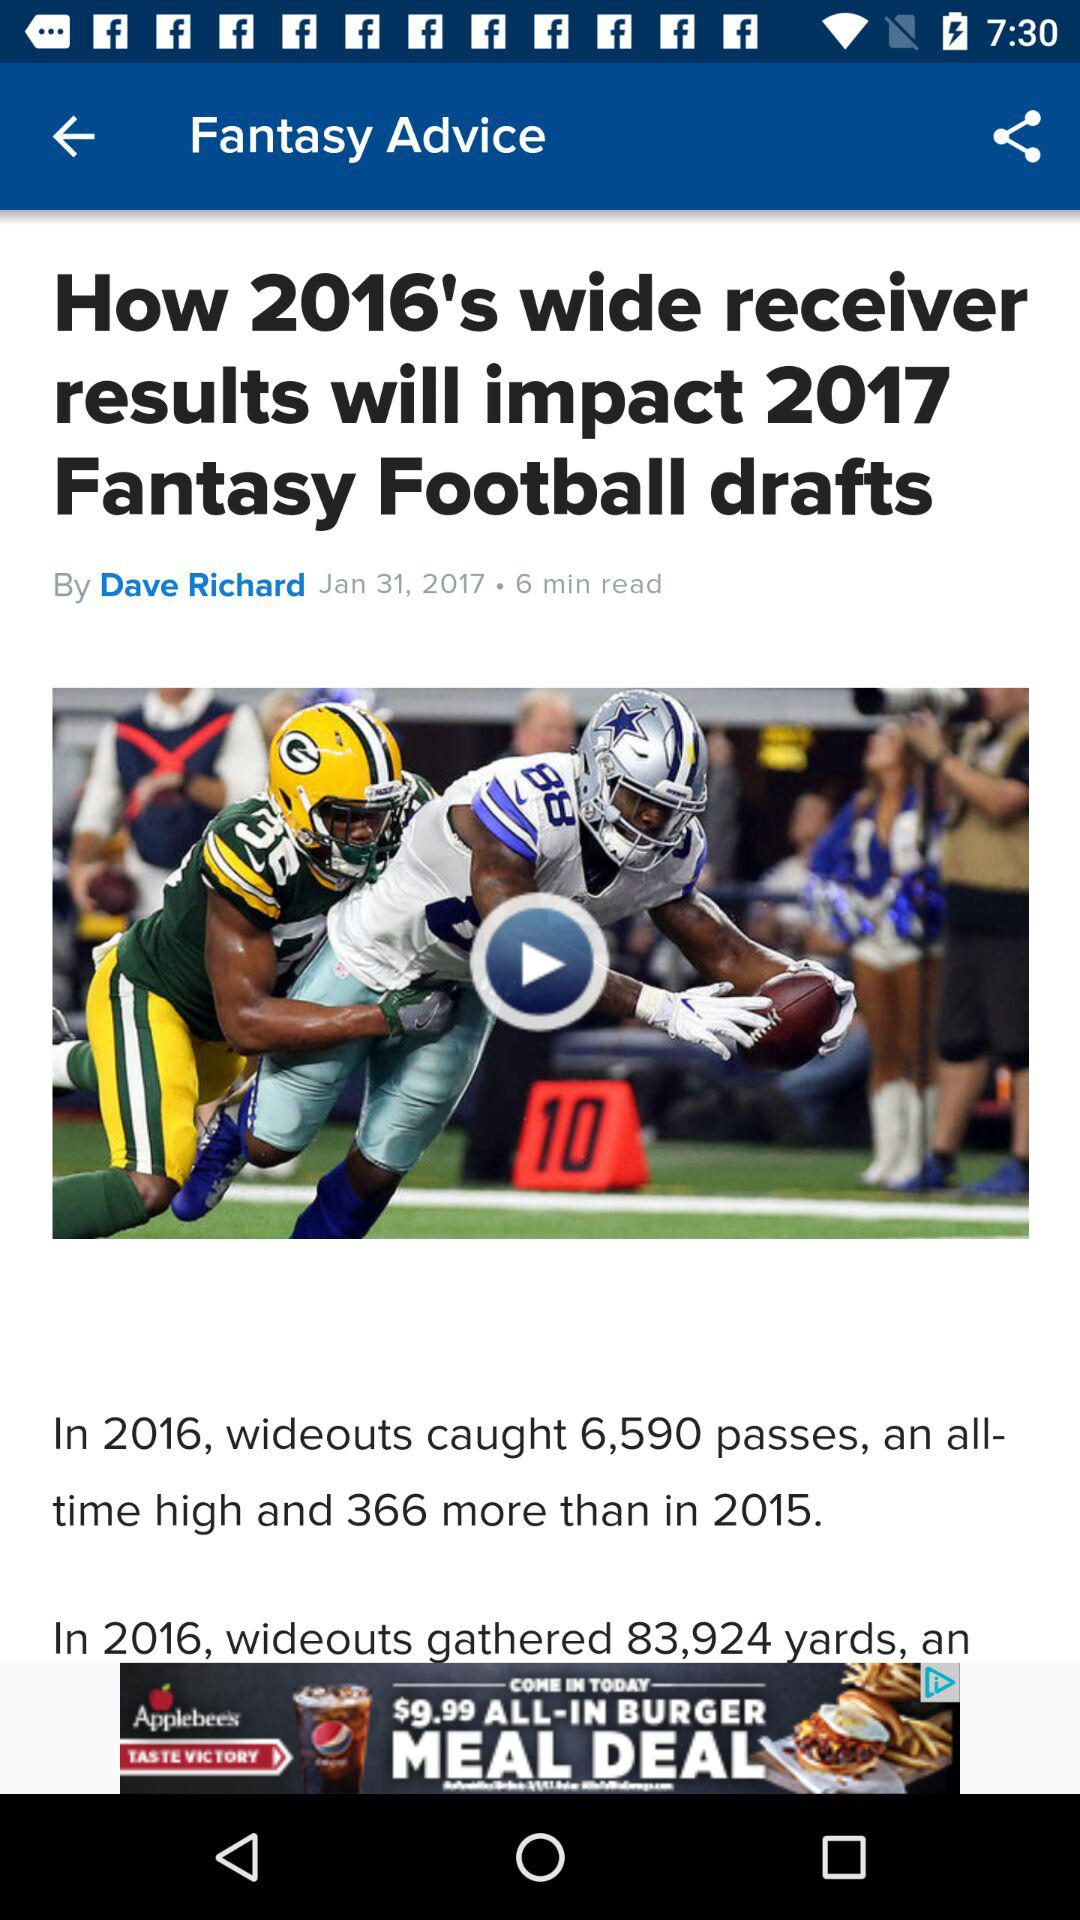What is the posted date of "How 2016's wide receiver results will impact 2017 Fantasy Football drafts" in "Fantasy Advice"? The posted date of "How 2016's wide receiver results will impact 2017 Fantasy Football drafts" in "Fantasy Advice" is January 31, 2017. 